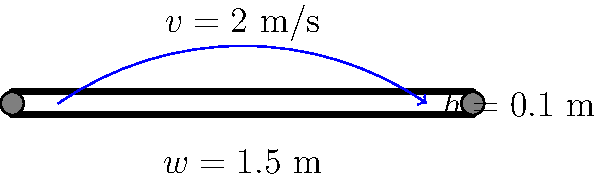A conveyor belt system is used to transport recyclable materials in a waste management facility. The belt moves at a constant speed of 2 m/s and has a width of 1.5 m. If the recyclable materials form a uniform layer with a height of 0.1 m on the belt, what is the volumetric flow rate of the materials in cubic meters per second (m³/s)? To solve this problem, we need to follow these steps:

1. Identify the given information:
   - Belt speed (v) = 2 m/s
   - Belt width (w) = 1.5 m
   - Material layer height (h) = 0.1 m

2. Understand that the volumetric flow rate is the volume of material passing a fixed point per unit time.

3. Calculate the cross-sectional area of the material on the belt:
   $A = w \times h = 1.5 \text{ m} \times 0.1 \text{ m} = 0.15 \text{ m}^2$

4. Calculate the volumetric flow rate using the formula:
   $Q = A \times v$
   Where:
   $Q$ is the volumetric flow rate (m³/s)
   $A$ is the cross-sectional area (m²)
   $v$ is the belt speed (m/s)

5. Substitute the values into the formula:
   $Q = 0.15 \text{ m}^2 \times 2 \text{ m/s} = 0.3 \text{ m}^3/\text{s}$

Therefore, the volumetric flow rate of recyclable materials on the conveyor belt is 0.3 m³/s.
Answer: 0.3 m³/s 